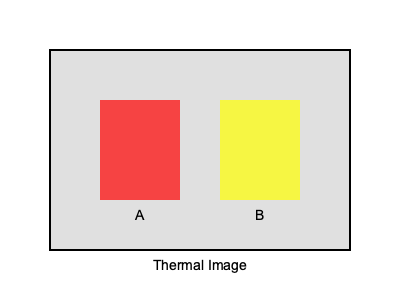Based on the thermal image of a building facade, which area (A or B) is likely to have higher heat loss and would benefit most from additional insulation in the architect's design? To analyze the heat loss patterns in this thermal image:

1. Understand thermal imaging colors:
   - Red/orange colors indicate higher temperatures
   - Yellow/green colors indicate moderate temperatures
   - Blue/purple colors indicate lower temperatures

2. Analyze the image:
   - Area A is shown in red, indicating higher temperature
   - Area B is shown in yellow, indicating moderate temperature

3. Interpret the results:
   - Higher surface temperatures in thermal images often indicate areas of heat loss
   - Area A, being redder and thus warmer, is likely experiencing more heat loss

4. Consider insulation needs:
   - Areas with higher heat loss benefit more from additional insulation
   - Improving insulation in area A would have a greater impact on overall energy efficiency

5. Relate to renewable energy systems:
   - Reducing heat loss through better insulation complements renewable energy systems by decreasing overall energy demand

Therefore, area A would benefit most from additional insulation in the architect's design, as it shows higher heat loss.
Answer: Area A 